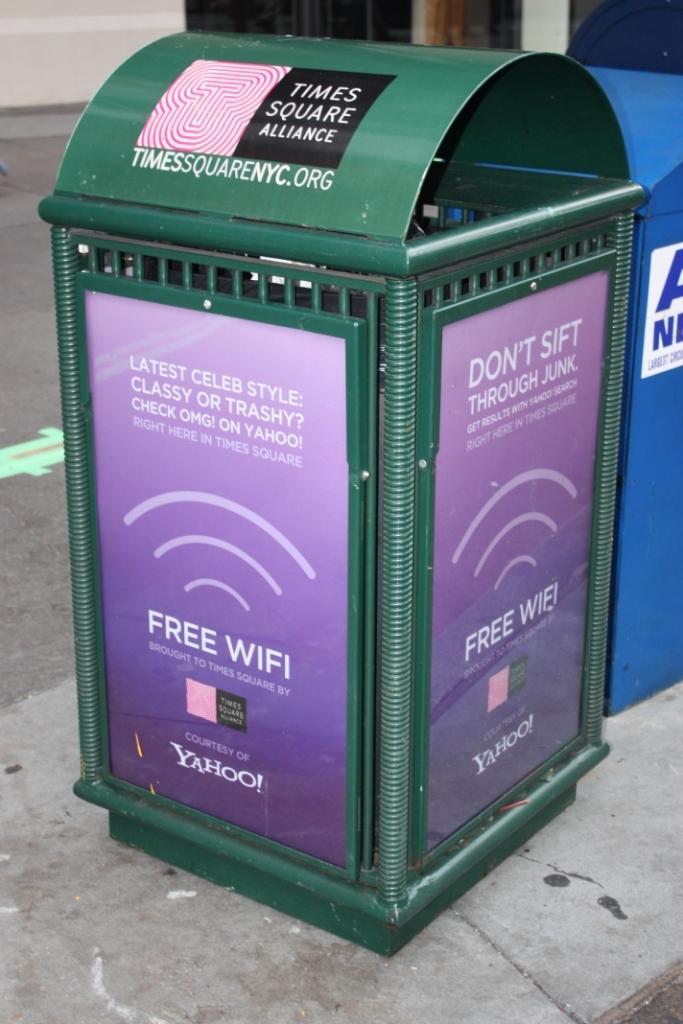<image>
Create a compact narrative representing the image presented. A green trash can with Times Square Alliance advertised. 